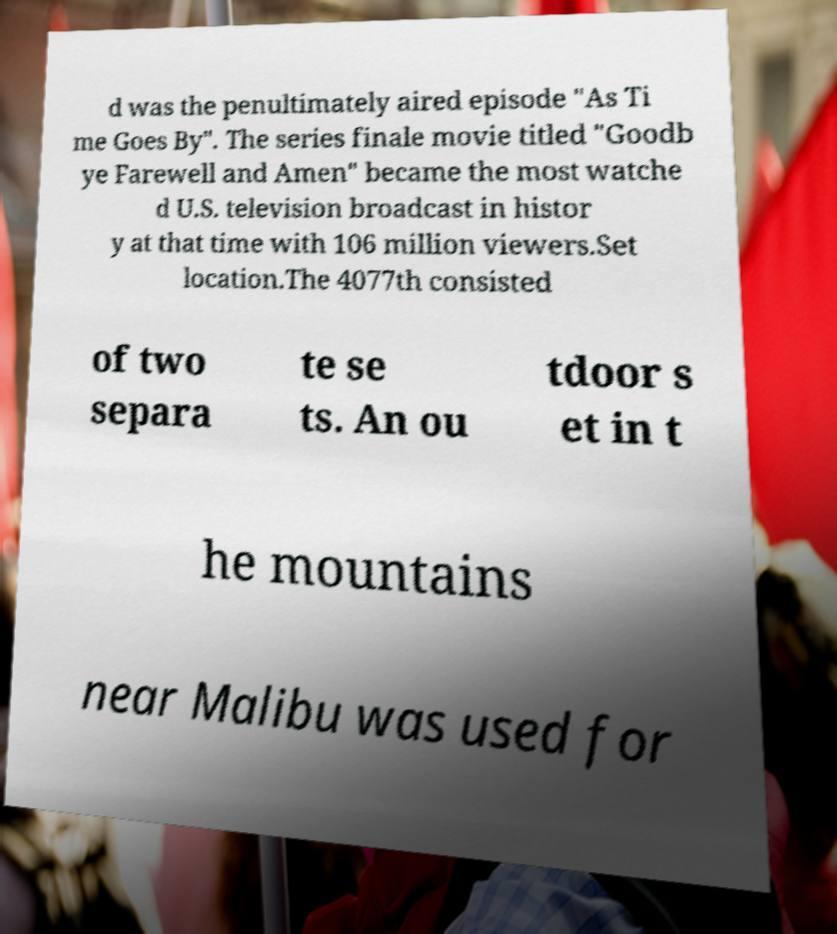Please read and relay the text visible in this image. What does it say? d was the penultimately aired episode "As Ti me Goes By". The series finale movie titled "Goodb ye Farewell and Amen" became the most watche d U.S. television broadcast in histor y at that time with 106 million viewers.Set location.The 4077th consisted of two separa te se ts. An ou tdoor s et in t he mountains near Malibu was used for 